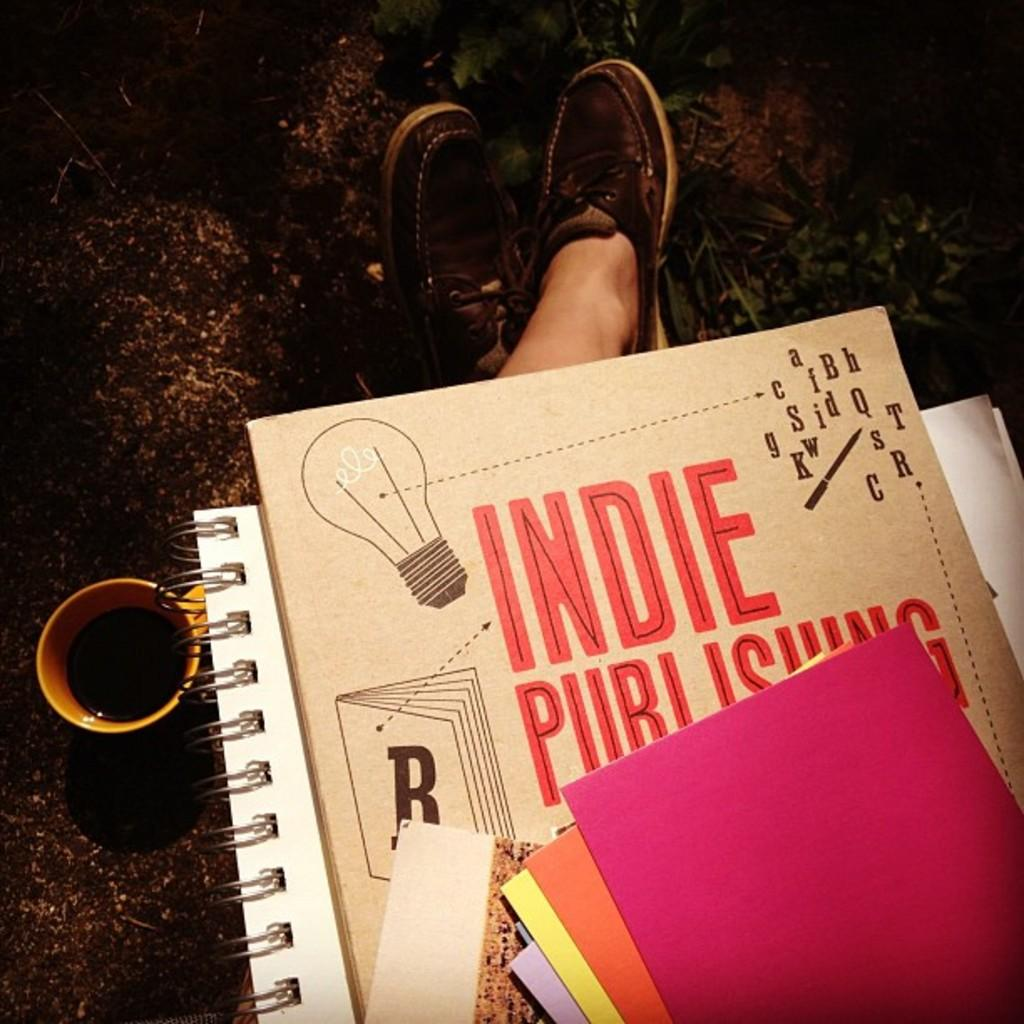<image>
Summarize the visual content of the image. A book cover shows the title Indie Publishing 